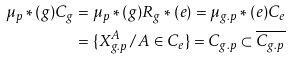<formula> <loc_0><loc_0><loc_500><loc_500>\mu _ { p } \ast ( g ) C _ { g } & = \mu _ { p } \ast ( g ) R _ { g } \ast ( e ) = \mu _ { g . p } \ast ( e ) C _ { e } \\ & = \{ X ^ { A } _ { g . p } \, / \, A \in C _ { e } \} = C _ { g . p } \subset \overline { C _ { g . p } }</formula> 